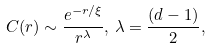<formula> <loc_0><loc_0><loc_500><loc_500>C ( r ) \sim \frac { e ^ { - r / \xi } } { r ^ { \lambda } } , \, \lambda = \frac { ( d - 1 ) } { 2 } ,</formula> 